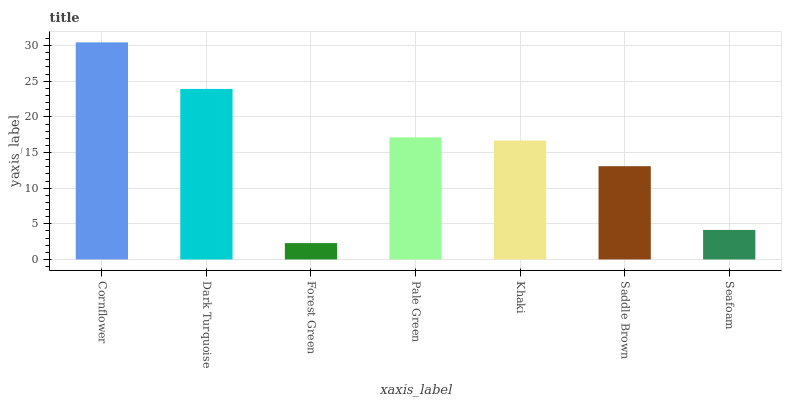Is Forest Green the minimum?
Answer yes or no. Yes. Is Cornflower the maximum?
Answer yes or no. Yes. Is Dark Turquoise the minimum?
Answer yes or no. No. Is Dark Turquoise the maximum?
Answer yes or no. No. Is Cornflower greater than Dark Turquoise?
Answer yes or no. Yes. Is Dark Turquoise less than Cornflower?
Answer yes or no. Yes. Is Dark Turquoise greater than Cornflower?
Answer yes or no. No. Is Cornflower less than Dark Turquoise?
Answer yes or no. No. Is Khaki the high median?
Answer yes or no. Yes. Is Khaki the low median?
Answer yes or no. Yes. Is Seafoam the high median?
Answer yes or no. No. Is Pale Green the low median?
Answer yes or no. No. 